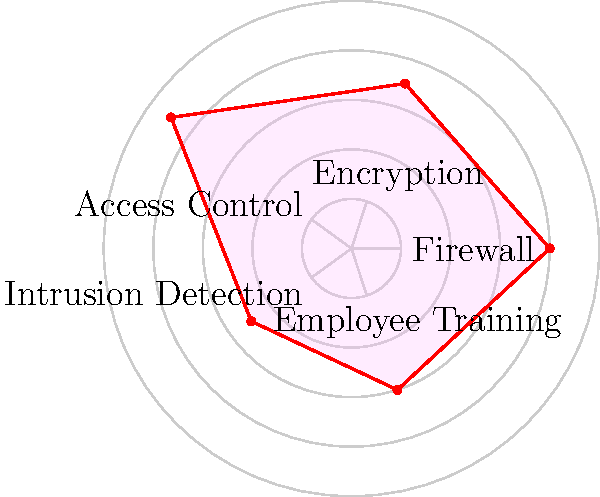Based on the radar chart depicting the effectiveness of various security measures in a financial institution, which measure appears to be the most effective, and which one requires the most improvement? To answer this question, we need to analyze the radar chart and compare the values for each security measure. The chart shows five security measures: Firewall, Encryption, Access Control, Intrusion Detection, and Employee Training. The effectiveness of each measure is represented by its distance from the center of the chart, with higher values indicating greater effectiveness.

Let's examine each measure:

1. Firewall: The value is approximately 4 out of 5.
2. Encryption: The value is approximately 3.5 out of 5.
3. Access Control: The value is approximately 4.5 out of 5.
4. Intrusion Detection: The value is approximately 2.5 out of 5.
5. Employee Training: The value is approximately 3 out of 5.

Comparing these values:

- The highest value is for Access Control at 4.5, making it the most effective security measure.
- The lowest value is for Intrusion Detection at 2.5, indicating that it requires the most improvement.
Answer: Most effective: Access Control. Needs most improvement: Intrusion Detection. 